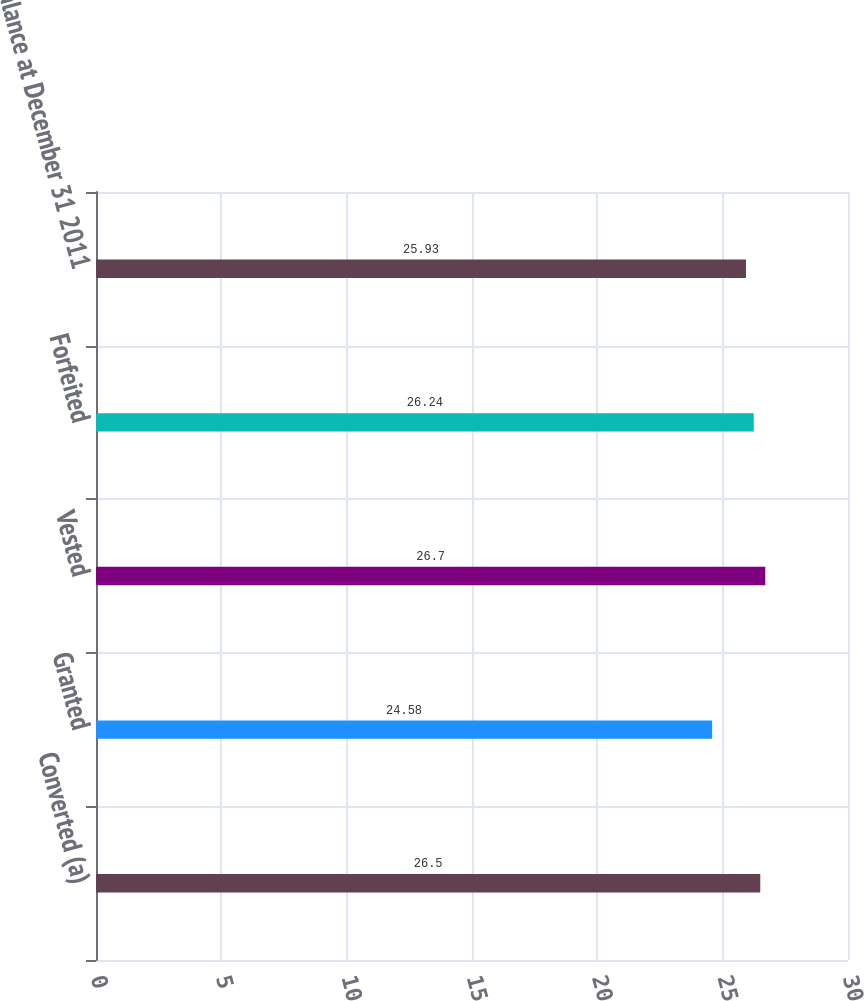Convert chart. <chart><loc_0><loc_0><loc_500><loc_500><bar_chart><fcel>Converted (a)<fcel>Granted<fcel>Vested<fcel>Forfeited<fcel>Balance at December 31 2011<nl><fcel>26.5<fcel>24.58<fcel>26.7<fcel>26.24<fcel>25.93<nl></chart> 